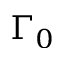<formula> <loc_0><loc_0><loc_500><loc_500>\Gamma _ { 0 }</formula> 